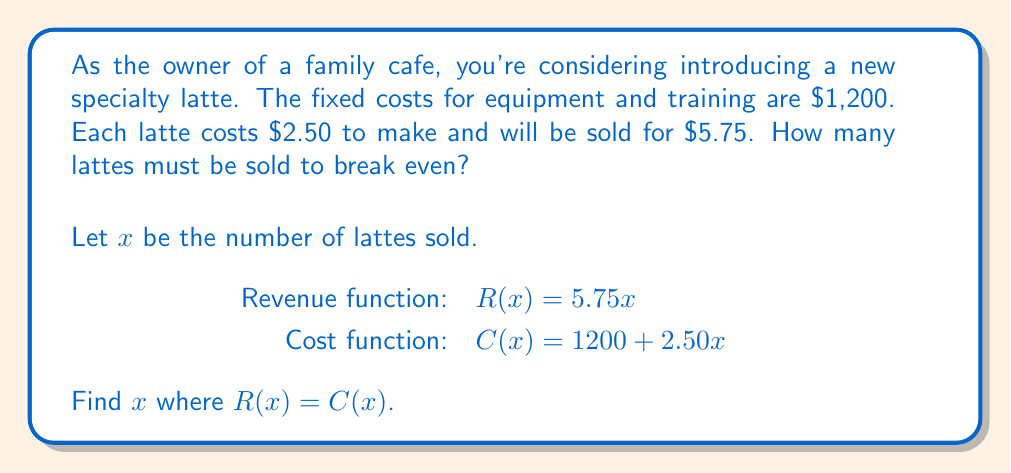Show me your answer to this math problem. To find the break-even point, we need to solve the equation where revenue equals cost:

$R(x) = C(x)$

Substituting the given functions:

$5.75x = 1200 + 2.50x$

Now, let's solve this equation step-by-step:

1) Subtract $2.50x$ from both sides:
   $3.25x = 1200$

2) Divide both sides by 3.25:
   $x = \frac{1200}{3.25}$

3) Calculate the result:
   $x = 369.23076923...$

Since we can't sell a fraction of a latte, we need to round up to the next whole number.

Therefore, the cafe needs to sell 370 lattes to break even.

To verify:
Revenue: $R(370) = 5.75 \times 370 = 2127.50$
Cost: $C(370) = 1200 + 2.50 \times 370 = 2125$

The slight difference is due to rounding, but this confirms the break-even point.
Answer: 370 lattes 